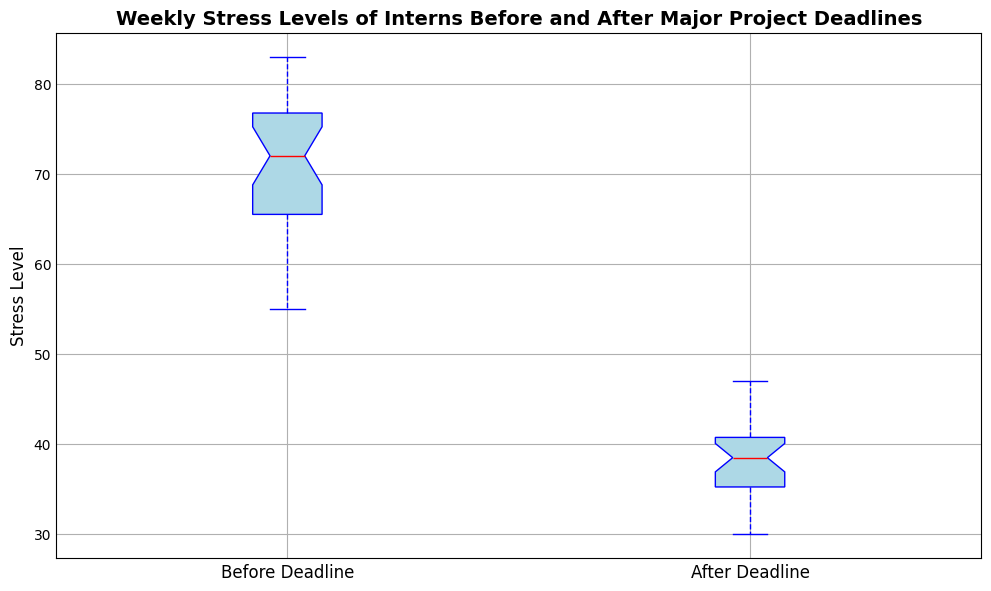What are the median stress level values before and after the deadline? To find the median values, look at the red lines in the center of the box plots for both 'Before Deadline' and 'After Deadline' categories. Match these lines with the y-axis values.
Answer: 71.5 before, 38 after Which category has a wider spread in stress levels? To determine the wider spread, compare the height of the boxes and the length of the whiskers for 'Before Deadline' and 'After Deadline'. The box with longer whiskers and a taller box indicates a wider spread.
Answer: Before Deadline What is the interquartile range (IQR) before the deadline? The IQR is the length of the box, which represents the difference between the third quartile (top edge of the box) and the first quartile (bottom edge of the box). Measure these y-axis points visually.
Answer: Approximately 13 How does the median stress level change from before to after the deadline? Locate the medians (red lines) of both box plots. Subtract the median after the deadline from the median before the deadline to find the change.
Answer: Decreases by 33.5 Are there any noticeable outliers in the data? If so, which categories do they belong to? Outliers are represented by individual points outside the whiskers. Identify whether any such points exist and which category they belong to.
Answer: No noticeable outliers Which category, before or after the deadline, has the lowest minimum stress level? Look at the lower whiskers of each box plot to see which one reaches the lowest point on the y-axis.
Answer: After Deadline What visual cues indicate the difference in stress levels before and after deadlines? Observe the difference in color, height, and position of medians, and the overall variance indicated by the boxes and whiskers between the two categories.
Answer: Higher box and median for 'Before Deadline', more compact and lower for 'After Deadline' Which category seems to have more consistent stress levels based on the box plot? Consistency is indicated by a smaller IQR and shorter whiskers, reflecting less variance. Compare these elements in both categories.
Answer: After Deadline What is the maximum stress level observed for interns before the deadline? Identify the top of the upper whisker for the 'Before Deadline' box plot and match it with the y-axis.
Answer: Approximately 83 How do the median stress levels compare with the average stress levels in each category? Calculate the average stress levels from the data provided. Compare these values with the median values derived from the graph.
Answer: Median values are 71.5 before, 38 after; average values are roughly similar, detailed calculation needed 